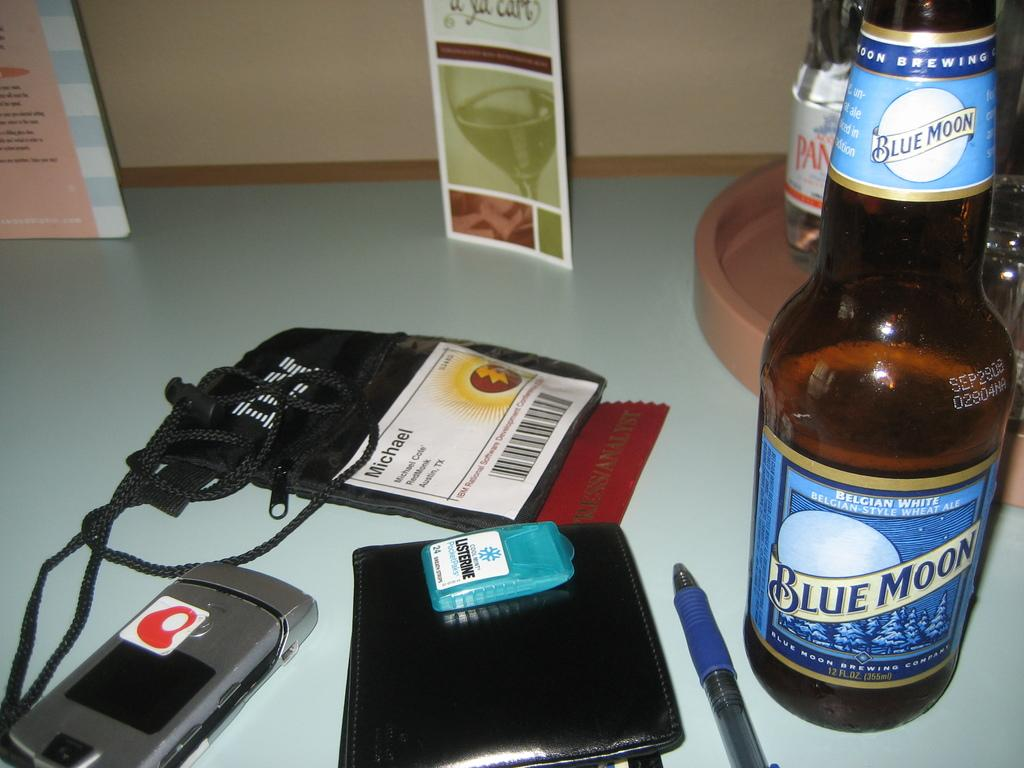What type of furniture is present in the image? There is a table in the image. What items can be seen on the table? There are wine bottles, a pen, a wallet, a mobile phone, and an ID card on the table. Can you describe the items related to communication or identification? The pen and ID card are related to communication and identification, respectively. What type of fog can be seen in the image? There is no fog present in the image. What historical event is depicted in the image? There is no historical event depicted in the image; it features a table with various items on it. 